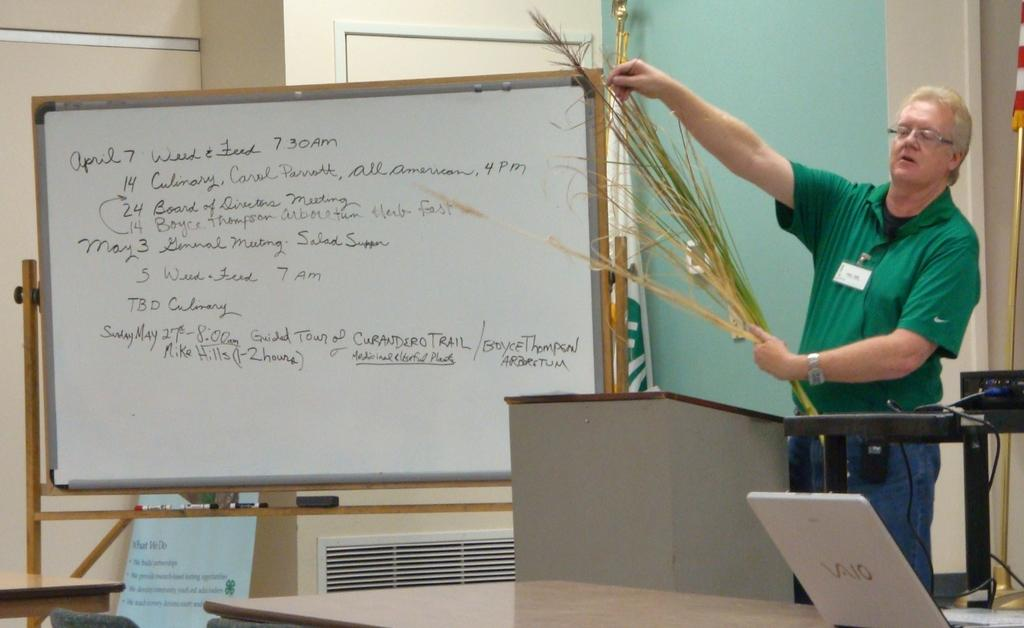<image>
Present a compact description of the photo's key features. A man stands besides a white board that has the date of April 7th. 